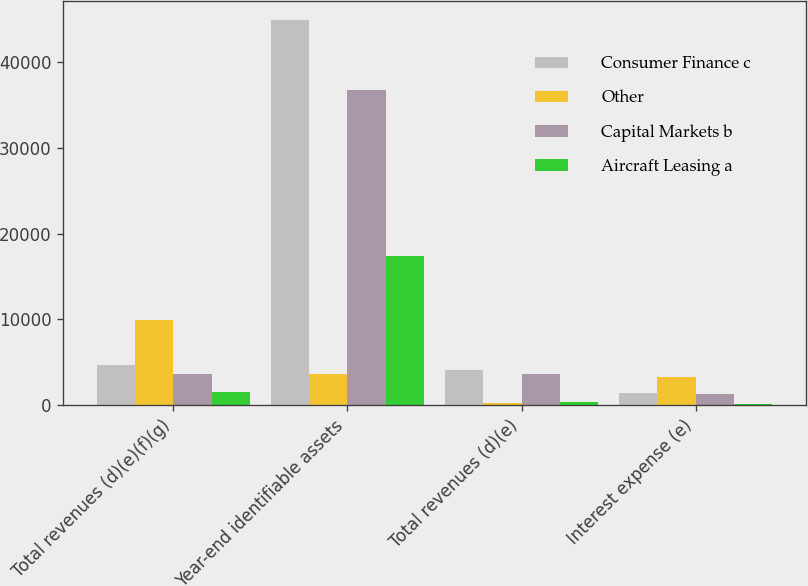Convert chart to OTSL. <chart><loc_0><loc_0><loc_500><loc_500><stacked_bar_chart><ecel><fcel>Total revenues (d)(e)(f)(g)<fcel>Year-end identifiable assets<fcel>Total revenues (d)(e)<fcel>Interest expense (e)<nl><fcel>Consumer Finance c<fcel>4694<fcel>44970<fcel>4082<fcel>1442<nl><fcel>Other<fcel>9979<fcel>3587<fcel>186<fcel>3215<nl><fcel>Capital Markets b<fcel>3655<fcel>36822<fcel>3587<fcel>1303<nl><fcel>Aircraft Leasing a<fcel>1471<fcel>17357<fcel>320<fcel>108<nl></chart> 